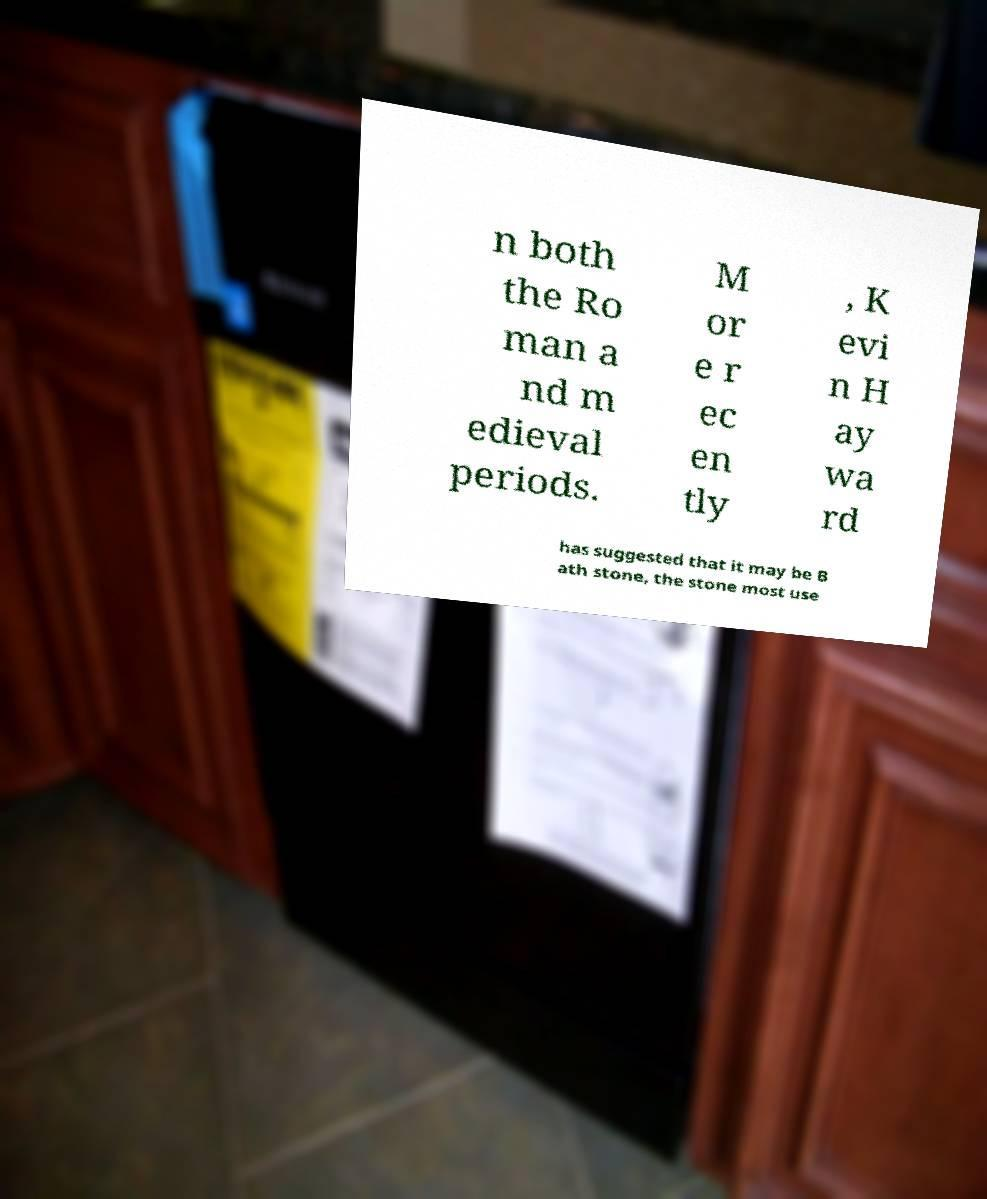Please identify and transcribe the text found in this image. n both the Ro man a nd m edieval periods. M or e r ec en tly , K evi n H ay wa rd has suggested that it may be B ath stone, the stone most use 